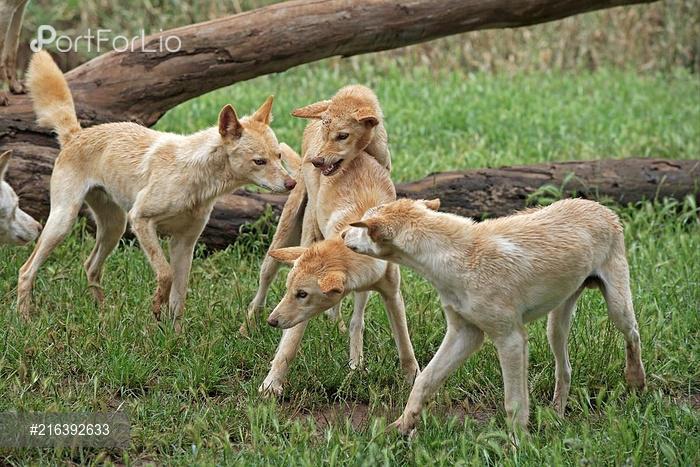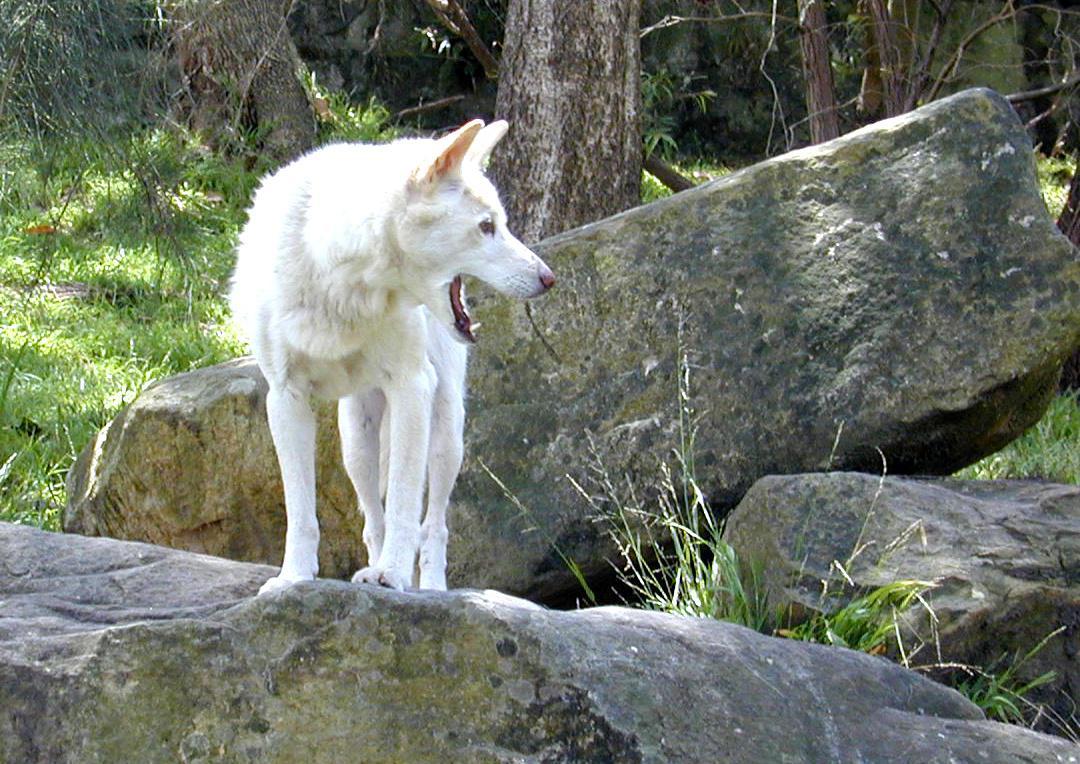The first image is the image on the left, the second image is the image on the right. Assess this claim about the two images: "there are 2 wolves, one is in the back laying down under a shrub with willowy leaves, there is dirt under them with dead leaves on the ground". Correct or not? Answer yes or no. No. The first image is the image on the left, the second image is the image on the right. For the images displayed, is the sentence "There are two wolves  outside with at least one laying down in the dirt." factually correct? Answer yes or no. No. 